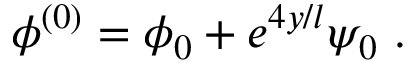<formula> <loc_0><loc_0><loc_500><loc_500>\phi ^ { ( 0 ) } = \phi _ { 0 } + e ^ { 4 y / l } \psi _ { 0 } \ .</formula> 